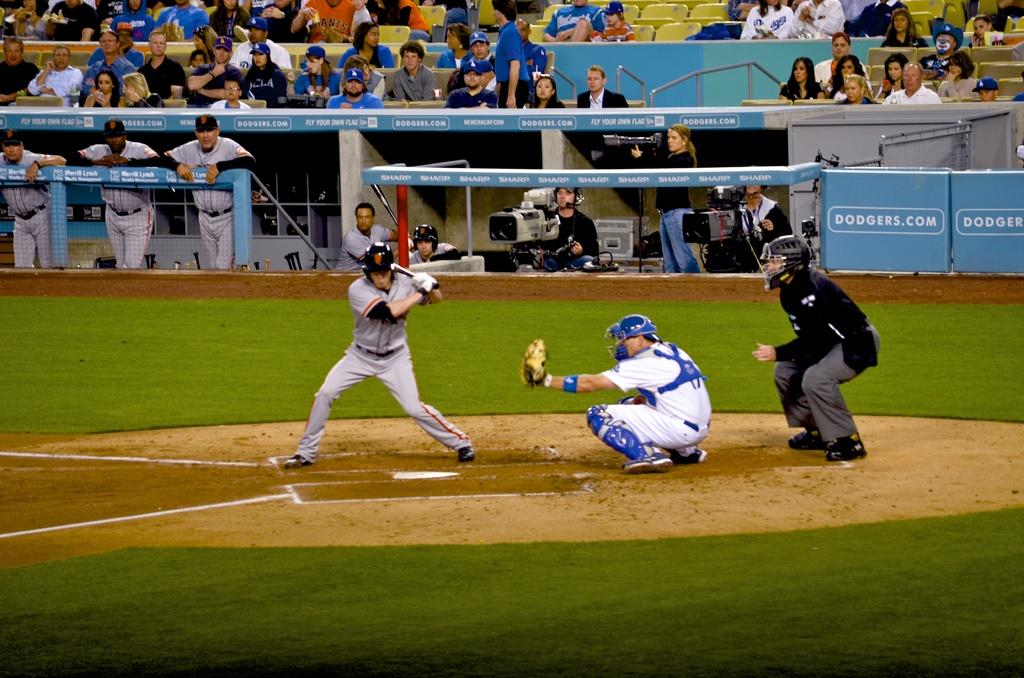<image>
Create a compact narrative representing the image presented. The side of the baseball field has the website dodgers.com displayed. 